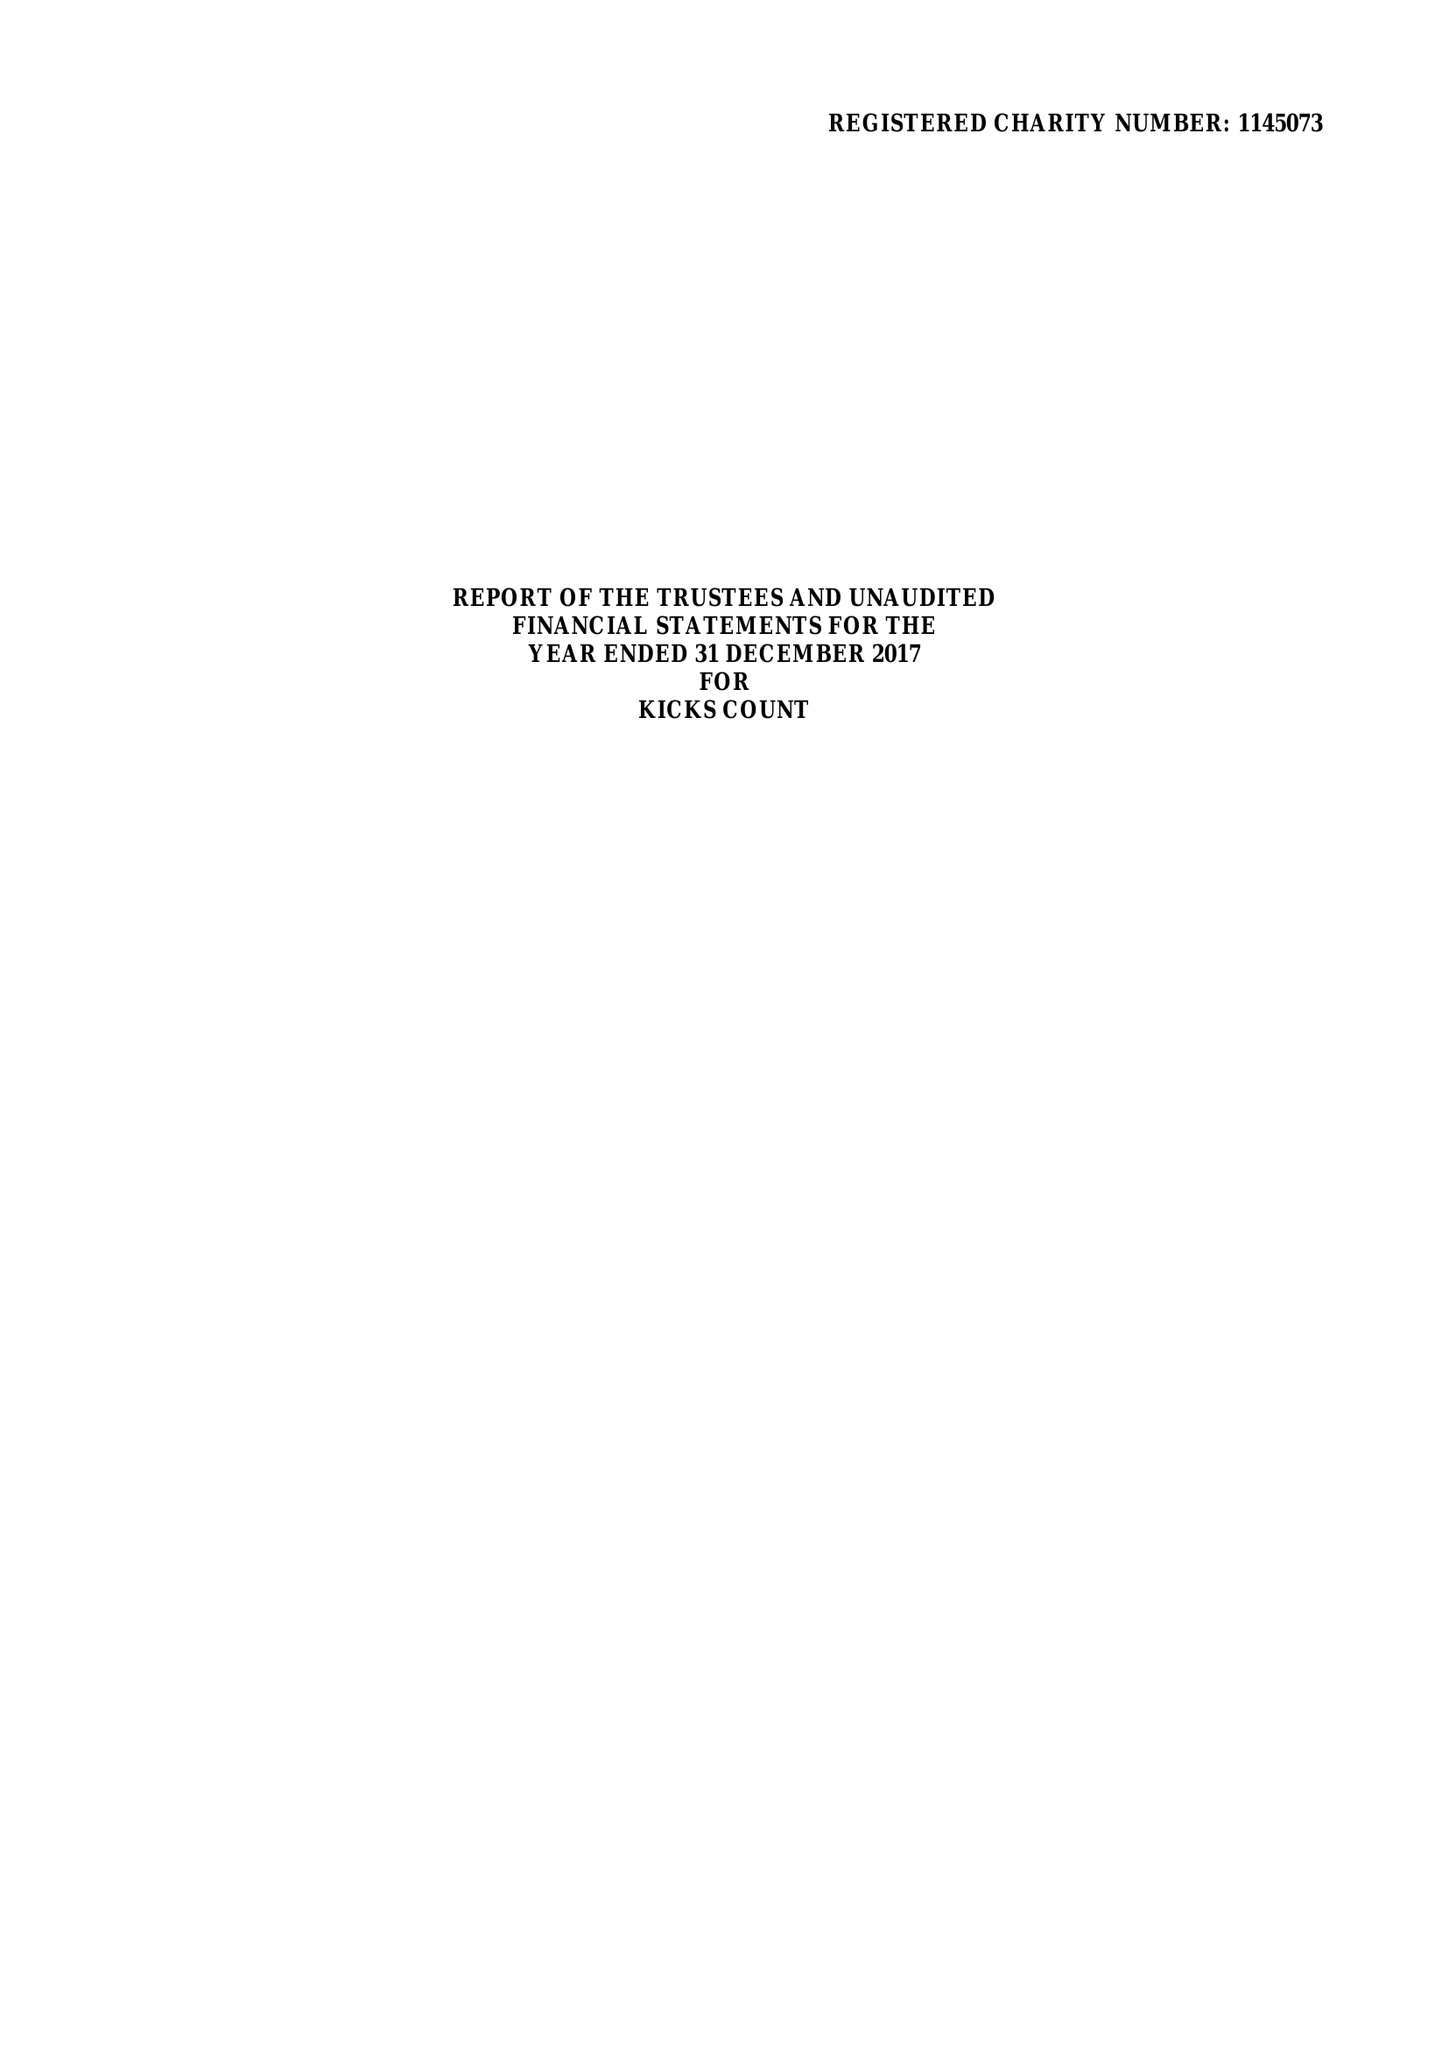What is the value for the charity_number?
Answer the question using a single word or phrase. 1145073 